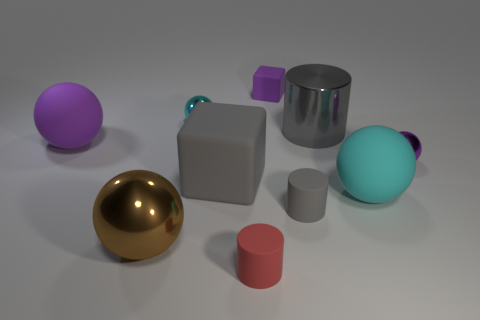What size is the cyan shiny object?
Offer a very short reply. Small. What is the material of the purple ball that is the same size as the gray matte cube?
Ensure brevity in your answer.  Rubber. There is a shiny cylinder; how many small purple objects are right of it?
Your answer should be very brief. 1. Do the purple ball to the right of the gray matte block and the tiny cyan object behind the big gray metal thing have the same material?
Your answer should be compact. Yes. What is the shape of the purple object to the left of the cyan thing that is behind the big ball right of the cyan metal thing?
Provide a succinct answer. Sphere. There is a tiny gray rubber object; what shape is it?
Make the answer very short. Cylinder. What shape is the brown metallic thing that is the same size as the cyan matte sphere?
Make the answer very short. Sphere. How many other things are the same color as the small block?
Your answer should be compact. 2. Do the cyan object that is left of the big gray shiny cylinder and the cyan object to the right of the small red matte thing have the same shape?
Your answer should be compact. Yes. What number of objects are either large shiny objects on the right side of the tiny cyan metallic ball or shiny spheres in front of the small purple metal thing?
Your answer should be very brief. 2. 